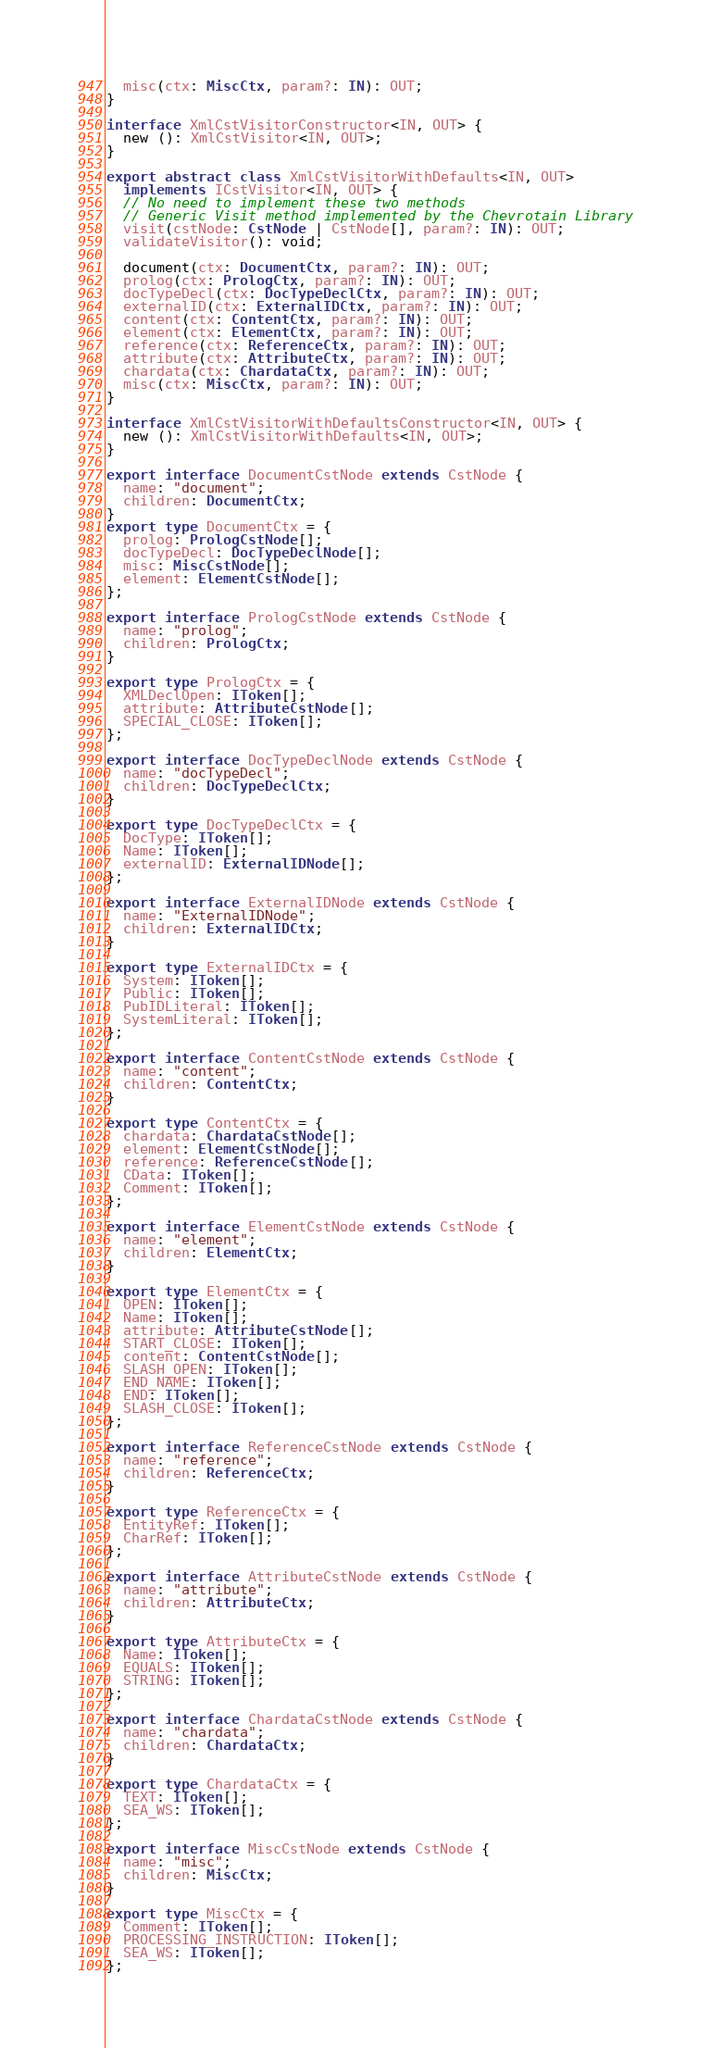Convert code to text. <code><loc_0><loc_0><loc_500><loc_500><_TypeScript_>  misc(ctx: MiscCtx, param?: IN): OUT;
}

interface XmlCstVisitorConstructor<IN, OUT> {
  new (): XmlCstVisitor<IN, OUT>;
}

export abstract class XmlCstVisitorWithDefaults<IN, OUT>
  implements ICstVisitor<IN, OUT> {
  // No need to implement these two methods
  // Generic Visit method implemented by the Chevrotain Library
  visit(cstNode: CstNode | CstNode[], param?: IN): OUT;
  validateVisitor(): void;

  document(ctx: DocumentCtx, param?: IN): OUT;
  prolog(ctx: PrologCtx, param?: IN): OUT;
  docTypeDecl(ctx: DocTypeDeclCtx, param?: IN): OUT;
  externalID(ctx: ExternalIDCtx, param?: IN): OUT;
  content(ctx: ContentCtx, param?: IN): OUT;
  element(ctx: ElementCtx, param?: IN): OUT;
  reference(ctx: ReferenceCtx, param?: IN): OUT;
  attribute(ctx: AttributeCtx, param?: IN): OUT;
  chardata(ctx: ChardataCtx, param?: IN): OUT;
  misc(ctx: MiscCtx, param?: IN): OUT;
}

interface XmlCstVisitorWithDefaultsConstructor<IN, OUT> {
  new (): XmlCstVisitorWithDefaults<IN, OUT>;
}

export interface DocumentCstNode extends CstNode {
  name: "document";
  children: DocumentCtx;
}
export type DocumentCtx = {
  prolog: PrologCstNode[];
  docTypeDecl: DocTypeDeclNode[];
  misc: MiscCstNode[];
  element: ElementCstNode[];
};

export interface PrologCstNode extends CstNode {
  name: "prolog";
  children: PrologCtx;
}

export type PrologCtx = {
  XMLDeclOpen: IToken[];
  attribute: AttributeCstNode[];
  SPECIAL_CLOSE: IToken[];
};

export interface DocTypeDeclNode extends CstNode {
  name: "docTypeDecl";
  children: DocTypeDeclCtx;
}

export type DocTypeDeclCtx = {
  DocType: IToken[];
  Name: IToken[];
  externalID: ExternalIDNode[];
};

export interface ExternalIDNode extends CstNode {
  name: "ExternalIDNode";
  children: ExternalIDCtx;
}

export type ExternalIDCtx = {
  System: IToken[];
  Public: IToken[];
  PubIDLiteral: IToken[];
  SystemLiteral: IToken[];
};

export interface ContentCstNode extends CstNode {
  name: "content";
  children: ContentCtx;
}

export type ContentCtx = {
  chardata: ChardataCstNode[];
  element: ElementCstNode[];
  reference: ReferenceCstNode[];
  CData: IToken[];
  Comment: IToken[];
};

export interface ElementCstNode extends CstNode {
  name: "element";
  children: ElementCtx;
}

export type ElementCtx = {
  OPEN: IToken[];
  Name: IToken[];
  attribute: AttributeCstNode[];
  START_CLOSE: IToken[];
  content: ContentCstNode[];
  SLASH_OPEN: IToken[];
  END_NAME: IToken[];
  END: IToken[];
  SLASH_CLOSE: IToken[];
};

export interface ReferenceCstNode extends CstNode {
  name: "reference";
  children: ReferenceCtx;
}

export type ReferenceCtx = {
  EntityRef: IToken[];
  CharRef: IToken[];
};

export interface AttributeCstNode extends CstNode {
  name: "attribute";
  children: AttributeCtx;
}

export type AttributeCtx = {
  Name: IToken[];
  EQUALS: IToken[];
  STRING: IToken[];
};

export interface ChardataCstNode extends CstNode {
  name: "chardata";
  children: ChardataCtx;
}

export type ChardataCtx = {
  TEXT: IToken[];
  SEA_WS: IToken[];
};

export interface MiscCstNode extends CstNode {
  name: "misc";
  children: MiscCtx;
}

export type MiscCtx = {
  Comment: IToken[];
  PROCESSING_INSTRUCTION: IToken[];
  SEA_WS: IToken[];
};
</code> 